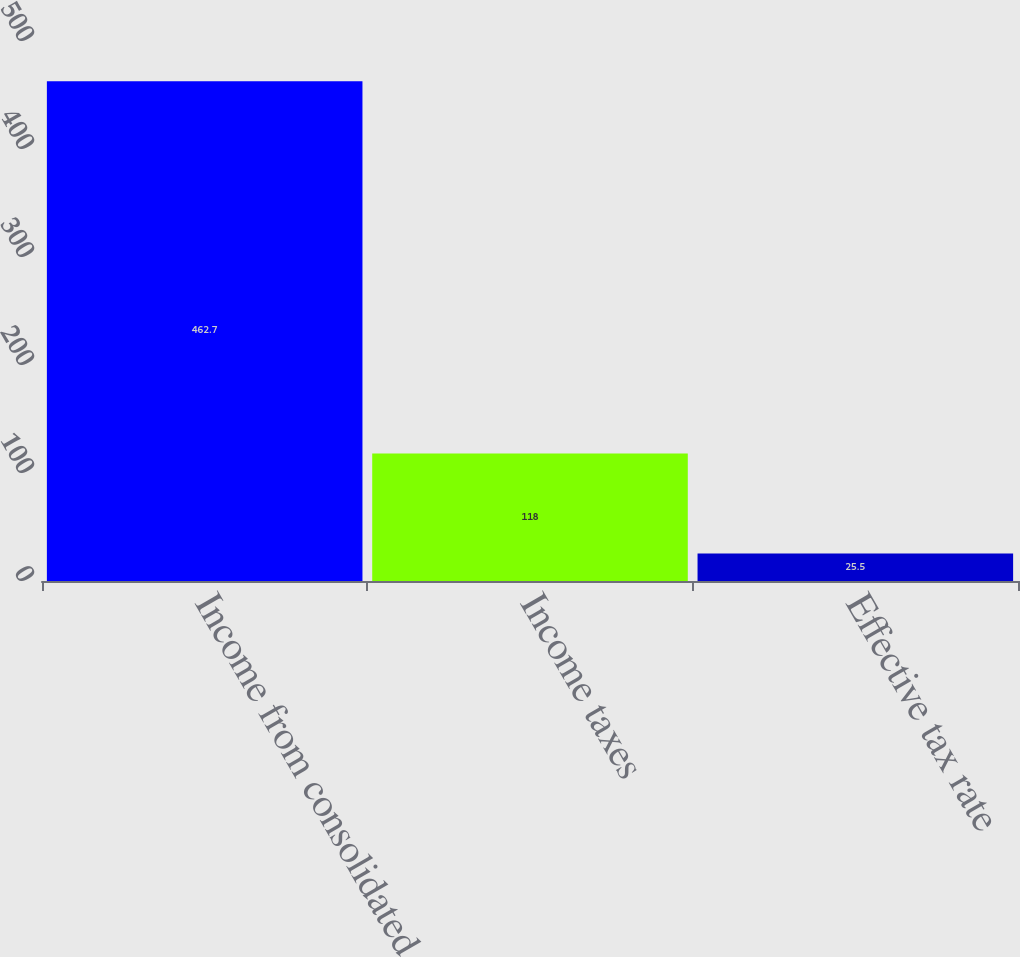Convert chart. <chart><loc_0><loc_0><loc_500><loc_500><bar_chart><fcel>Income from consolidated<fcel>Income taxes<fcel>Effective tax rate<nl><fcel>462.7<fcel>118<fcel>25.5<nl></chart> 